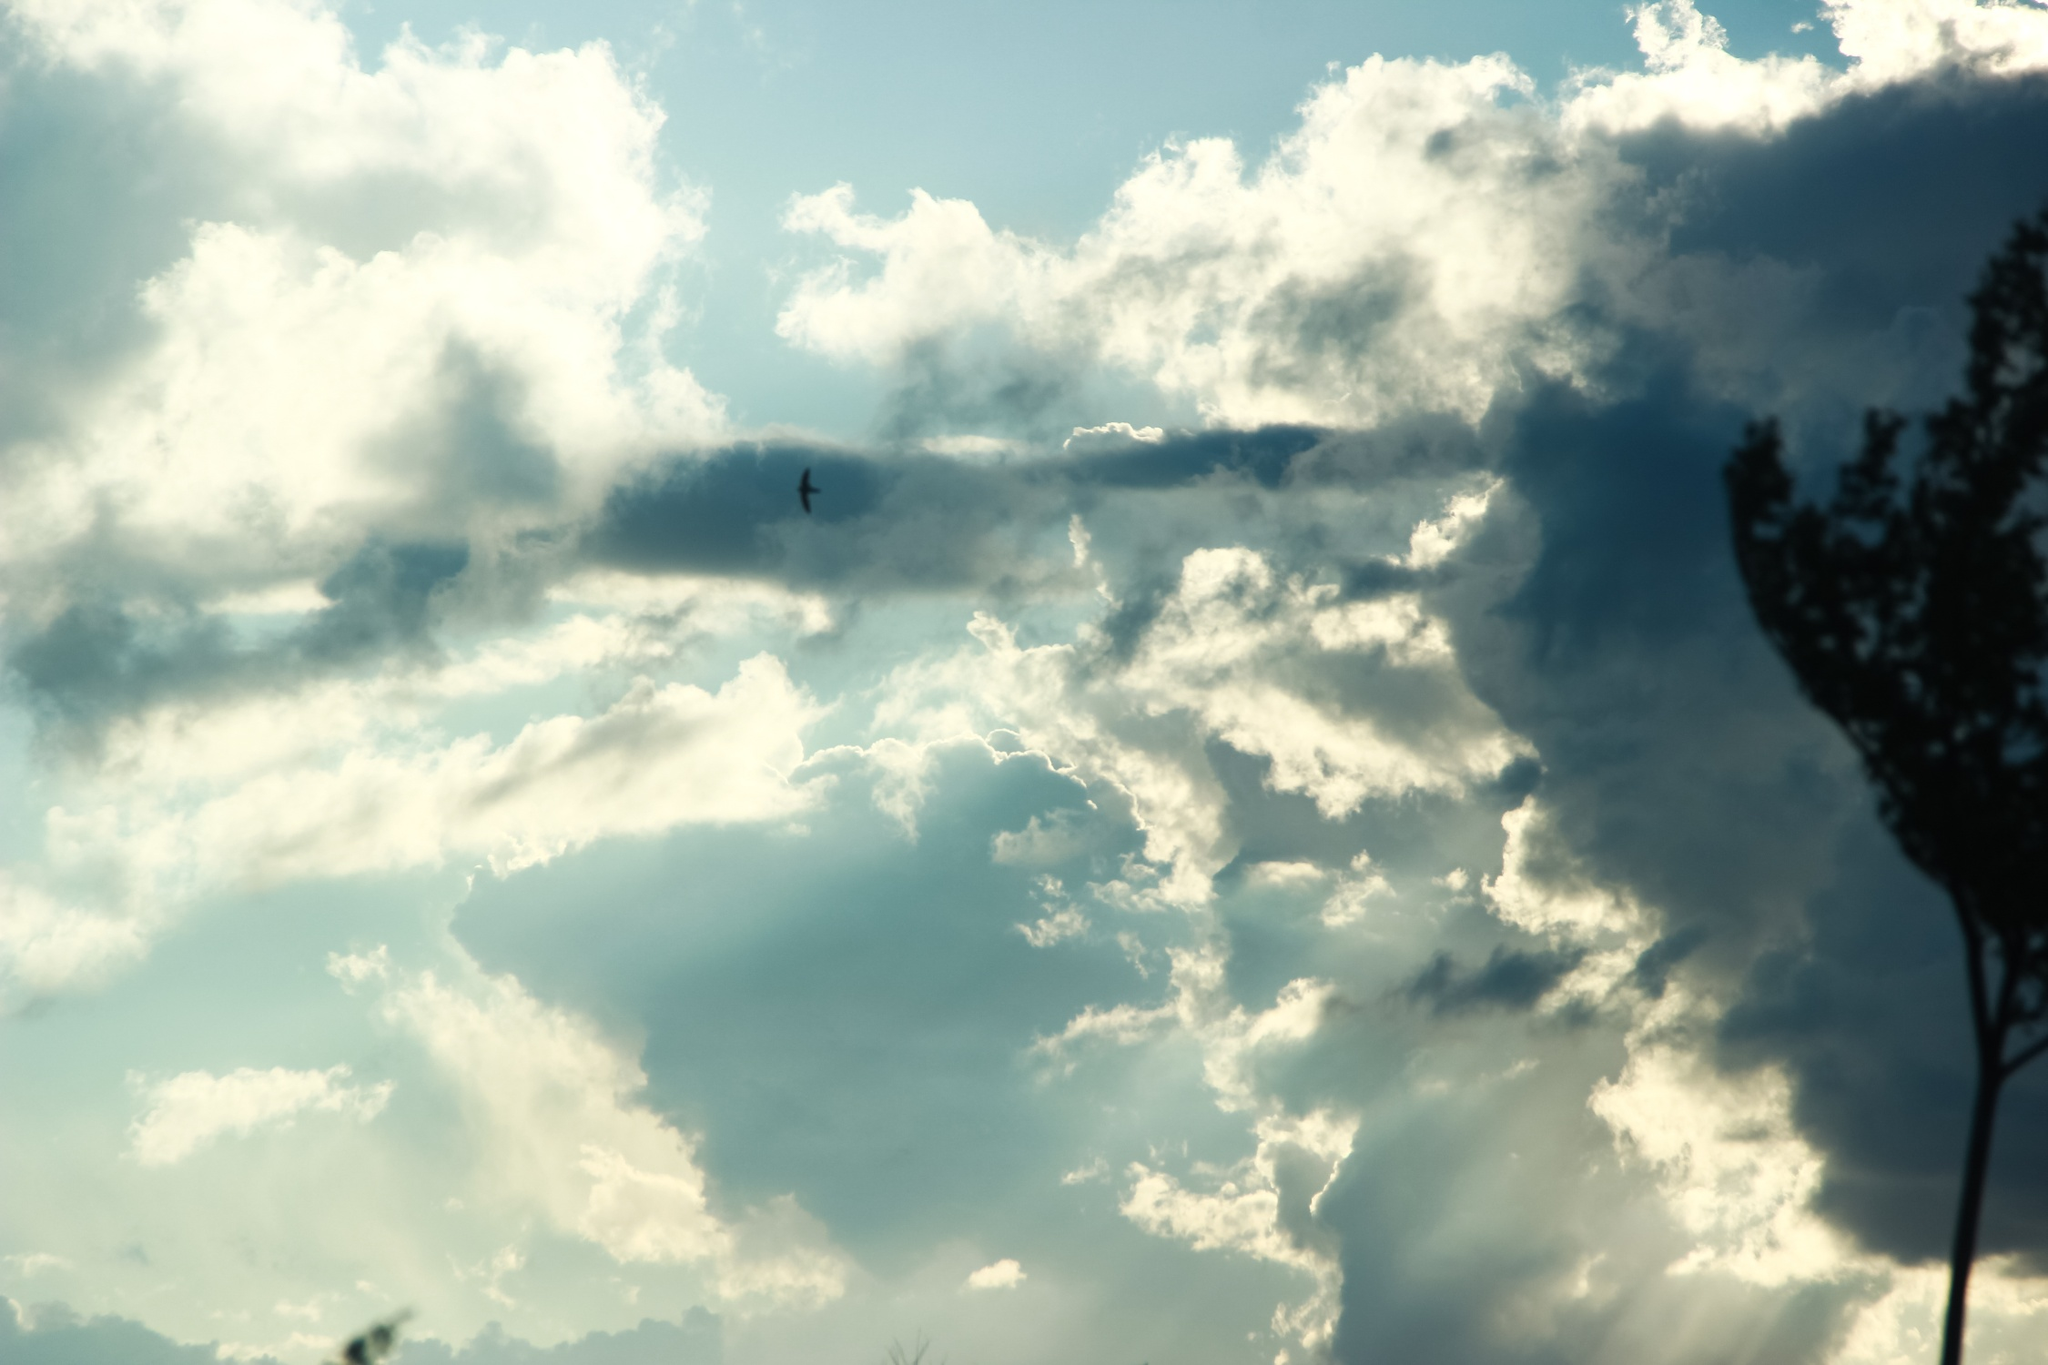Create a dialogue between two birds captured in this scene. Bird 1: 'Look at these clouds today, aren't they magnificent?' 

Bird 2: 'Absolutely, the contrast is quite dramatic. Perfect day for a flight, don't you think?' 

Bird 1: 'Indeed. It's days like these that make you feel grateful for the freedom of the skies.' 

Bird 2: 'I heard a legend about this old tree, you know. They say it holds the wisdom of countless seasons.' 

Bird 1: 'Oh really? I always thought of it as just a place to rest. Maybe tomorrow, we should sit on its branches and listen to its stories.' 

Bird 2: 'That sounds like a plan. Until then, let's enjoy the wind beneath our wings and the liberty of the open sky.' 